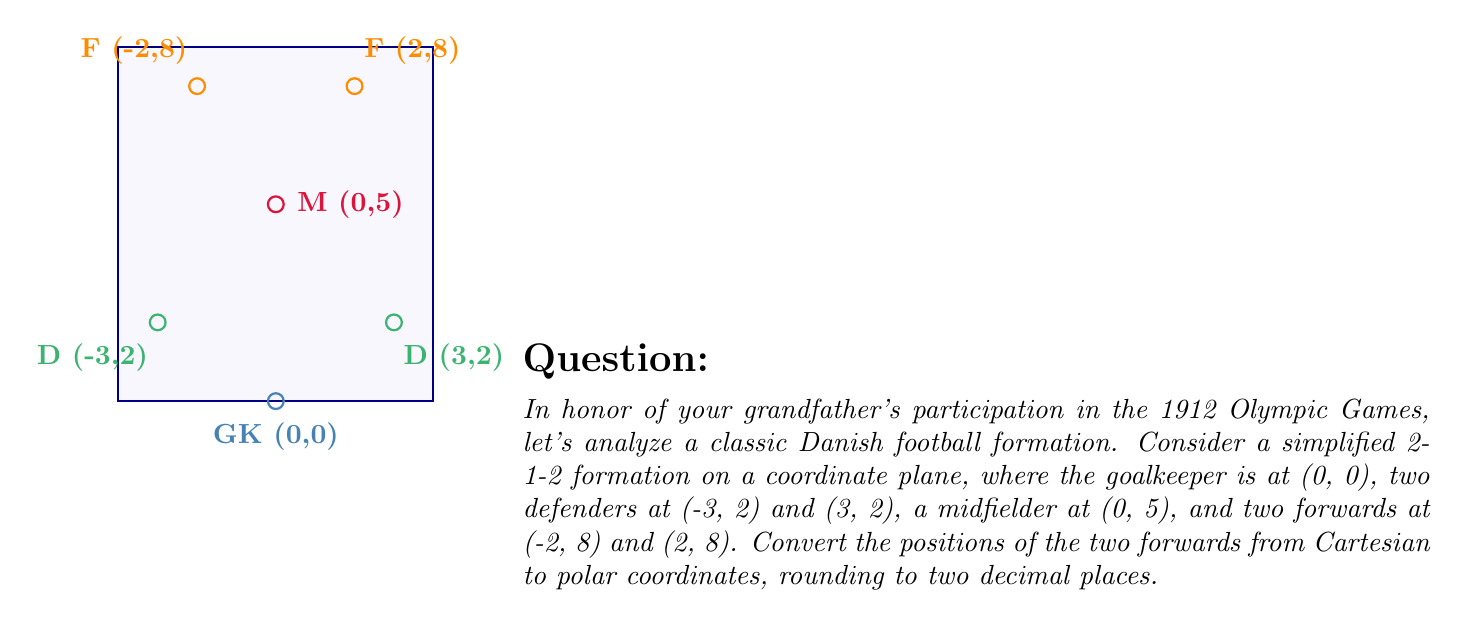Can you solve this math problem? To convert from Cartesian coordinates (x, y) to polar coordinates (r, θ), we use the following formulas:

1. $r = \sqrt{x^2 + y^2}$
2. $\theta = \tan^{-1}(\frac{y}{x})$

For the left forward at (-2, 8):

1. Calculate r:
   $r = \sqrt{(-2)^2 + 8^2} = \sqrt{4 + 64} = \sqrt{68} \approx 8.25$

2. Calculate θ:
   $\theta = \tan^{-1}(\frac{8}{-2}) = \tan^{-1}(-4)$
   
   However, since x is negative and y is positive, we need to add π to this result:
   $\theta = \tan^{-1}(-4) + \pi \approx -1.33 + 3.14 \approx 1.81$ radians

For the right forward at (2, 8):

1. Calculate r:
   $r = \sqrt{2^2 + 8^2} = \sqrt{4 + 64} = \sqrt{68} \approx 8.25$

2. Calculate θ:
   $\theta = \tan^{-1}(\frac{8}{2}) = \tan^{-1}(4) \approx 1.33$ radians

Rounding to two decimal places, we get:
Left forward: (8.25, 1.81)
Right forward: (8.25, 1.33)
Answer: Left forward: (8.25, 1.81), Right forward: (8.25, 1.33) 